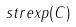Convert formula to latex. <formula><loc_0><loc_0><loc_500><loc_500>s t r e x p ( C )</formula> 